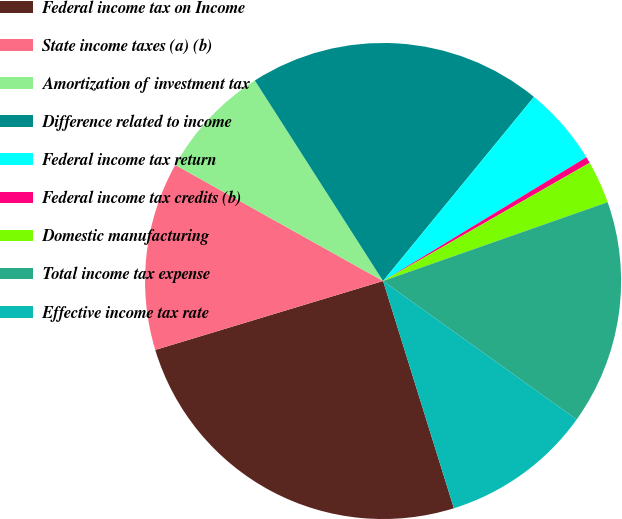Convert chart to OTSL. <chart><loc_0><loc_0><loc_500><loc_500><pie_chart><fcel>Federal income tax on Income<fcel>State income taxes (a) (b)<fcel>Amortization of investment tax<fcel>Difference related to income<fcel>Federal income tax return<fcel>Federal income tax credits (b)<fcel>Domestic manufacturing<fcel>Total income tax expense<fcel>Effective income tax rate<nl><fcel>25.13%<fcel>12.78%<fcel>7.84%<fcel>19.98%<fcel>5.37%<fcel>0.43%<fcel>2.9%<fcel>15.25%<fcel>10.31%<nl></chart> 